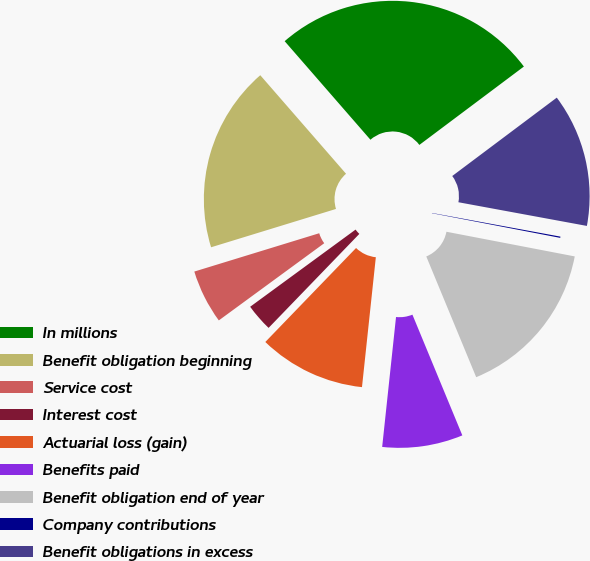Convert chart. <chart><loc_0><loc_0><loc_500><loc_500><pie_chart><fcel>In millions<fcel>Benefit obligation beginning<fcel>Service cost<fcel>Interest cost<fcel>Actuarial loss (gain)<fcel>Benefits paid<fcel>Benefit obligation end of year<fcel>Company contributions<fcel>Benefit obligations in excess<nl><fcel>26.16%<fcel>18.34%<fcel>5.32%<fcel>2.72%<fcel>10.53%<fcel>7.93%<fcel>15.74%<fcel>0.12%<fcel>13.14%<nl></chart> 